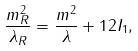<formula> <loc_0><loc_0><loc_500><loc_500>\frac { m _ { R } ^ { 2 } } { \lambda _ { R } } = \frac { m ^ { 2 } } { \lambda } + 1 2 I _ { 1 } ,</formula> 